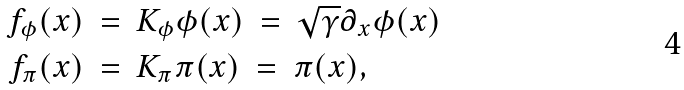Convert formula to latex. <formula><loc_0><loc_0><loc_500><loc_500>f _ { \phi } ( x ) \ & = \ K _ { \phi } \phi ( x ) \ = \ \sqrt { \gamma } \partial _ { x } \phi ( x ) \\ f _ { \pi } ( x ) \ & = \ K _ { \pi } \pi ( x ) \ = \ \pi ( x ) ,</formula> 